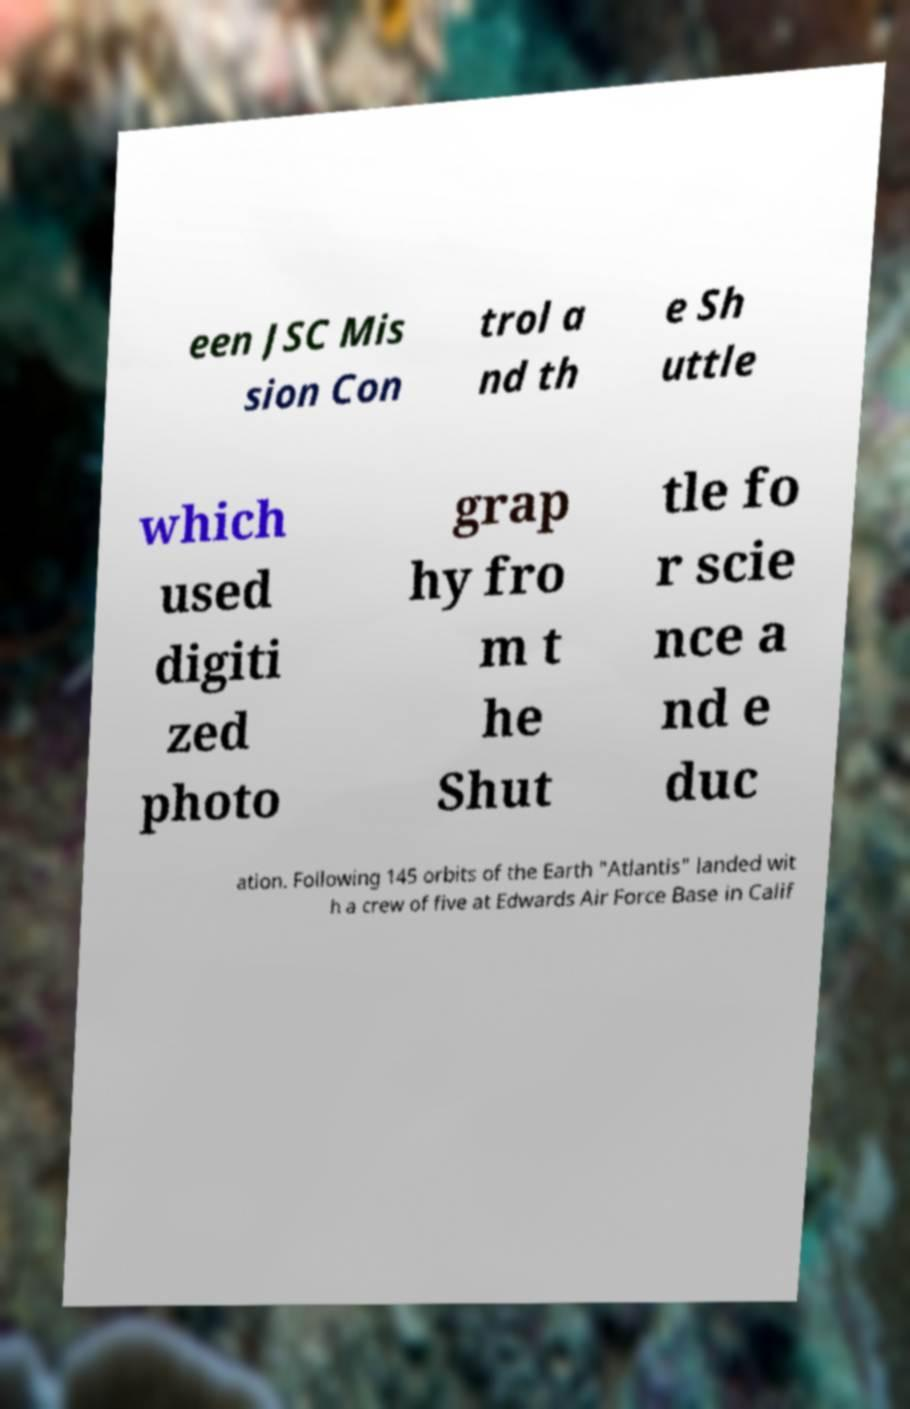Could you assist in decoding the text presented in this image and type it out clearly? een JSC Mis sion Con trol a nd th e Sh uttle which used digiti zed photo grap hy fro m t he Shut tle fo r scie nce a nd e duc ation. Following 145 orbits of the Earth "Atlantis" landed wit h a crew of five at Edwards Air Force Base in Calif 